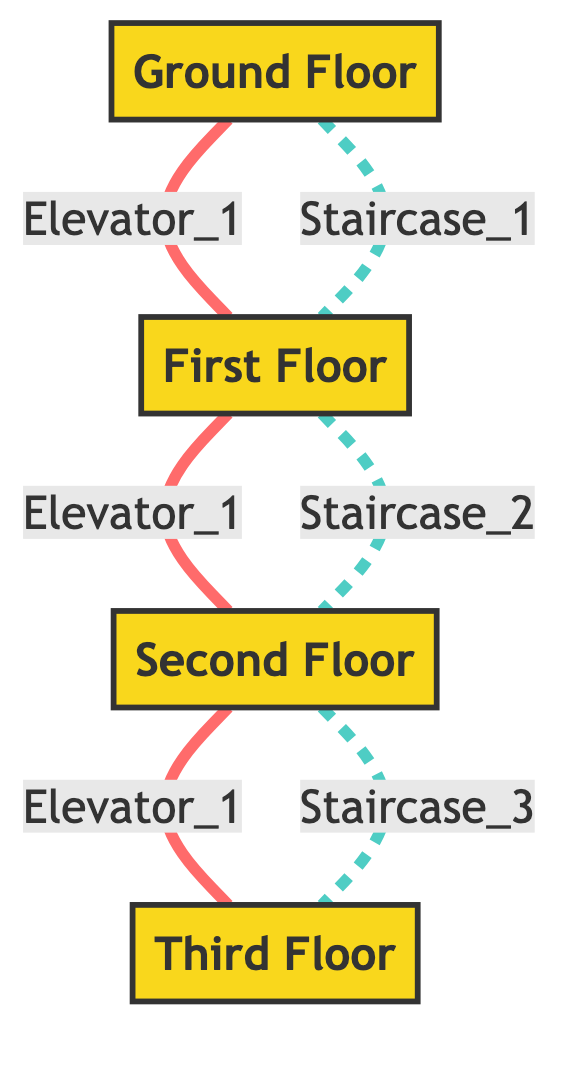What are the nodes in the graph? The graph contains four nodes, which represent different floors: Ground Floor, First Floor, Second Floor, and Third Floor.
Answer: Ground Floor, First Floor, Second Floor, Third Floor How many edges are there in the graph? The graph features a total of six edges. Three of these are elevators and three are staircases connecting the floors.
Answer: Six What connects the Ground Floor to the First Floor? The connection between the Ground Floor and the First Floor is established through both Elevator_1 and Staircase_1.
Answer: Elevator_1, Staircase_1 Which floor has no direct connection to the Second Floor? The Ground Floor has no direct connection to the Second Floor since there is no edge directly connecting these two nodes.
Answer: Ground Floor If someone is on the Second Floor, what options do they have to reach the Third Floor? To reach the Third Floor from the Second Floor, one can use either Elevator_1 or Staircase_2.
Answer: Elevator_1, Staircase_2 Are there more staircases or elevators in the diagram? There are an equal number of staircases and elevators, with three of each in the diagram.
Answer: Equal What type of connections exist between the floors? The connections between the floors consist of elevators and staircases, as indicated by the labels on the edges.
Answer: Elevators and Staircases Which edge connects the Third Floor to the Second Floor? The edge connecting the Third Floor to the Second Floor is labeled as Elevator_1 and Staircase_2.
Answer: Elevator_1, Staircase_2 